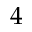Convert formula to latex. <formula><loc_0><loc_0><loc_500><loc_500>4</formula> 